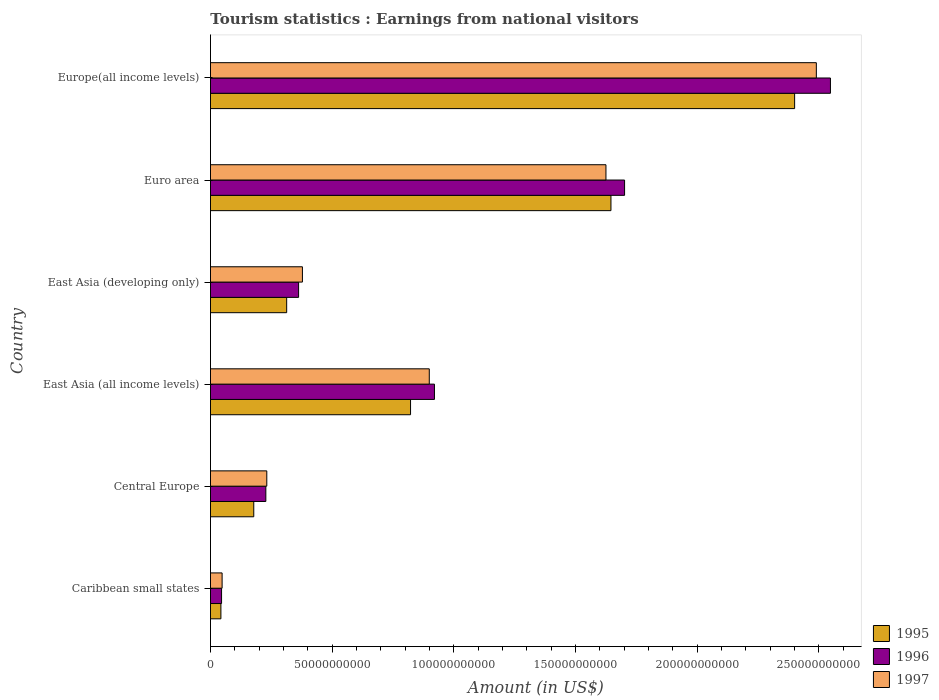How many groups of bars are there?
Make the answer very short. 6. Are the number of bars on each tick of the Y-axis equal?
Provide a short and direct response. Yes. How many bars are there on the 2nd tick from the top?
Provide a short and direct response. 3. How many bars are there on the 3rd tick from the bottom?
Provide a short and direct response. 3. What is the label of the 6th group of bars from the top?
Your answer should be compact. Caribbean small states. In how many cases, is the number of bars for a given country not equal to the number of legend labels?
Your response must be concise. 0. What is the earnings from national visitors in 1997 in Europe(all income levels)?
Your response must be concise. 2.49e+11. Across all countries, what is the maximum earnings from national visitors in 1997?
Give a very brief answer. 2.49e+11. Across all countries, what is the minimum earnings from national visitors in 1996?
Keep it short and to the point. 4.56e+09. In which country was the earnings from national visitors in 1996 maximum?
Provide a short and direct response. Europe(all income levels). In which country was the earnings from national visitors in 1995 minimum?
Provide a short and direct response. Caribbean small states. What is the total earnings from national visitors in 1996 in the graph?
Provide a succinct answer. 5.81e+11. What is the difference between the earnings from national visitors in 1997 in Central Europe and that in East Asia (developing only)?
Keep it short and to the point. -1.46e+1. What is the difference between the earnings from national visitors in 1997 in East Asia (all income levels) and the earnings from national visitors in 1996 in East Asia (developing only)?
Provide a succinct answer. 5.37e+1. What is the average earnings from national visitors in 1996 per country?
Your answer should be very brief. 9.68e+1. What is the difference between the earnings from national visitors in 1997 and earnings from national visitors in 1995 in East Asia (developing only)?
Your response must be concise. 6.47e+09. In how many countries, is the earnings from national visitors in 1997 greater than 90000000000 US$?
Make the answer very short. 2. What is the ratio of the earnings from national visitors in 1995 in East Asia (developing only) to that in Euro area?
Keep it short and to the point. 0.19. Is the earnings from national visitors in 1997 in East Asia (developing only) less than that in Europe(all income levels)?
Provide a succinct answer. Yes. What is the difference between the highest and the second highest earnings from national visitors in 1996?
Make the answer very short. 8.46e+1. What is the difference between the highest and the lowest earnings from national visitors in 1995?
Make the answer very short. 2.36e+11. What does the 3rd bar from the bottom in Caribbean small states represents?
Offer a very short reply. 1997. How many bars are there?
Provide a short and direct response. 18. How many countries are there in the graph?
Ensure brevity in your answer.  6. What is the difference between two consecutive major ticks on the X-axis?
Offer a terse response. 5.00e+1. Are the values on the major ticks of X-axis written in scientific E-notation?
Your response must be concise. No. How many legend labels are there?
Ensure brevity in your answer.  3. What is the title of the graph?
Offer a terse response. Tourism statistics : Earnings from national visitors. What is the label or title of the X-axis?
Give a very brief answer. Amount (in US$). What is the label or title of the Y-axis?
Give a very brief answer. Country. What is the Amount (in US$) in 1995 in Caribbean small states?
Provide a succinct answer. 4.29e+09. What is the Amount (in US$) of 1996 in Caribbean small states?
Provide a succinct answer. 4.56e+09. What is the Amount (in US$) in 1997 in Caribbean small states?
Give a very brief answer. 4.78e+09. What is the Amount (in US$) of 1995 in Central Europe?
Keep it short and to the point. 1.78e+1. What is the Amount (in US$) of 1996 in Central Europe?
Provide a short and direct response. 2.28e+1. What is the Amount (in US$) in 1997 in Central Europe?
Your response must be concise. 2.32e+1. What is the Amount (in US$) in 1995 in East Asia (all income levels)?
Ensure brevity in your answer.  8.22e+1. What is the Amount (in US$) in 1996 in East Asia (all income levels)?
Your response must be concise. 9.21e+1. What is the Amount (in US$) in 1997 in East Asia (all income levels)?
Your answer should be very brief. 8.99e+1. What is the Amount (in US$) of 1995 in East Asia (developing only)?
Your answer should be compact. 3.13e+1. What is the Amount (in US$) in 1996 in East Asia (developing only)?
Your answer should be very brief. 3.62e+1. What is the Amount (in US$) in 1997 in East Asia (developing only)?
Give a very brief answer. 3.78e+1. What is the Amount (in US$) in 1995 in Euro area?
Provide a short and direct response. 1.65e+11. What is the Amount (in US$) in 1996 in Euro area?
Keep it short and to the point. 1.70e+11. What is the Amount (in US$) of 1997 in Euro area?
Your answer should be very brief. 1.63e+11. What is the Amount (in US$) of 1995 in Europe(all income levels)?
Keep it short and to the point. 2.40e+11. What is the Amount (in US$) of 1996 in Europe(all income levels)?
Provide a succinct answer. 2.55e+11. What is the Amount (in US$) of 1997 in Europe(all income levels)?
Provide a succinct answer. 2.49e+11. Across all countries, what is the maximum Amount (in US$) in 1995?
Your response must be concise. 2.40e+11. Across all countries, what is the maximum Amount (in US$) in 1996?
Your response must be concise. 2.55e+11. Across all countries, what is the maximum Amount (in US$) of 1997?
Provide a succinct answer. 2.49e+11. Across all countries, what is the minimum Amount (in US$) in 1995?
Offer a very short reply. 4.29e+09. Across all countries, what is the minimum Amount (in US$) of 1996?
Your response must be concise. 4.56e+09. Across all countries, what is the minimum Amount (in US$) of 1997?
Provide a succinct answer. 4.78e+09. What is the total Amount (in US$) in 1995 in the graph?
Provide a succinct answer. 5.40e+11. What is the total Amount (in US$) in 1996 in the graph?
Ensure brevity in your answer.  5.81e+11. What is the total Amount (in US$) of 1997 in the graph?
Make the answer very short. 5.67e+11. What is the difference between the Amount (in US$) of 1995 in Caribbean small states and that in Central Europe?
Provide a succinct answer. -1.35e+1. What is the difference between the Amount (in US$) of 1996 in Caribbean small states and that in Central Europe?
Your answer should be compact. -1.82e+1. What is the difference between the Amount (in US$) of 1997 in Caribbean small states and that in Central Europe?
Keep it short and to the point. -1.84e+1. What is the difference between the Amount (in US$) of 1995 in Caribbean small states and that in East Asia (all income levels)?
Make the answer very short. -7.79e+1. What is the difference between the Amount (in US$) in 1996 in Caribbean small states and that in East Asia (all income levels)?
Make the answer very short. -8.75e+1. What is the difference between the Amount (in US$) of 1997 in Caribbean small states and that in East Asia (all income levels)?
Keep it short and to the point. -8.52e+1. What is the difference between the Amount (in US$) in 1995 in Caribbean small states and that in East Asia (developing only)?
Your answer should be very brief. -2.70e+1. What is the difference between the Amount (in US$) of 1996 in Caribbean small states and that in East Asia (developing only)?
Provide a short and direct response. -3.17e+1. What is the difference between the Amount (in US$) in 1997 in Caribbean small states and that in East Asia (developing only)?
Offer a terse response. -3.30e+1. What is the difference between the Amount (in US$) of 1995 in Caribbean small states and that in Euro area?
Give a very brief answer. -1.60e+11. What is the difference between the Amount (in US$) of 1996 in Caribbean small states and that in Euro area?
Your response must be concise. -1.66e+11. What is the difference between the Amount (in US$) of 1997 in Caribbean small states and that in Euro area?
Provide a succinct answer. -1.58e+11. What is the difference between the Amount (in US$) in 1995 in Caribbean small states and that in Europe(all income levels)?
Your response must be concise. -2.36e+11. What is the difference between the Amount (in US$) of 1996 in Caribbean small states and that in Europe(all income levels)?
Your response must be concise. -2.50e+11. What is the difference between the Amount (in US$) of 1997 in Caribbean small states and that in Europe(all income levels)?
Make the answer very short. -2.44e+11. What is the difference between the Amount (in US$) of 1995 in Central Europe and that in East Asia (all income levels)?
Offer a terse response. -6.44e+1. What is the difference between the Amount (in US$) in 1996 in Central Europe and that in East Asia (all income levels)?
Make the answer very short. -6.93e+1. What is the difference between the Amount (in US$) of 1997 in Central Europe and that in East Asia (all income levels)?
Ensure brevity in your answer.  -6.68e+1. What is the difference between the Amount (in US$) in 1995 in Central Europe and that in East Asia (developing only)?
Keep it short and to the point. -1.35e+1. What is the difference between the Amount (in US$) in 1996 in Central Europe and that in East Asia (developing only)?
Provide a succinct answer. -1.35e+1. What is the difference between the Amount (in US$) in 1997 in Central Europe and that in East Asia (developing only)?
Provide a succinct answer. -1.46e+1. What is the difference between the Amount (in US$) in 1995 in Central Europe and that in Euro area?
Give a very brief answer. -1.47e+11. What is the difference between the Amount (in US$) of 1996 in Central Europe and that in Euro area?
Your answer should be very brief. -1.47e+11. What is the difference between the Amount (in US$) in 1997 in Central Europe and that in Euro area?
Keep it short and to the point. -1.39e+11. What is the difference between the Amount (in US$) in 1995 in Central Europe and that in Europe(all income levels)?
Give a very brief answer. -2.22e+11. What is the difference between the Amount (in US$) of 1996 in Central Europe and that in Europe(all income levels)?
Make the answer very short. -2.32e+11. What is the difference between the Amount (in US$) of 1997 in Central Europe and that in Europe(all income levels)?
Give a very brief answer. -2.26e+11. What is the difference between the Amount (in US$) of 1995 in East Asia (all income levels) and that in East Asia (developing only)?
Your answer should be compact. 5.09e+1. What is the difference between the Amount (in US$) in 1996 in East Asia (all income levels) and that in East Asia (developing only)?
Keep it short and to the point. 5.58e+1. What is the difference between the Amount (in US$) in 1997 in East Asia (all income levels) and that in East Asia (developing only)?
Ensure brevity in your answer.  5.21e+1. What is the difference between the Amount (in US$) in 1995 in East Asia (all income levels) and that in Euro area?
Provide a succinct answer. -8.24e+1. What is the difference between the Amount (in US$) of 1996 in East Asia (all income levels) and that in Euro area?
Your response must be concise. -7.82e+1. What is the difference between the Amount (in US$) in 1997 in East Asia (all income levels) and that in Euro area?
Your response must be concise. -7.26e+1. What is the difference between the Amount (in US$) in 1995 in East Asia (all income levels) and that in Europe(all income levels)?
Your answer should be very brief. -1.58e+11. What is the difference between the Amount (in US$) in 1996 in East Asia (all income levels) and that in Europe(all income levels)?
Your answer should be compact. -1.63e+11. What is the difference between the Amount (in US$) of 1997 in East Asia (all income levels) and that in Europe(all income levels)?
Your response must be concise. -1.59e+11. What is the difference between the Amount (in US$) in 1995 in East Asia (developing only) and that in Euro area?
Your answer should be compact. -1.33e+11. What is the difference between the Amount (in US$) of 1996 in East Asia (developing only) and that in Euro area?
Your answer should be compact. -1.34e+11. What is the difference between the Amount (in US$) of 1997 in East Asia (developing only) and that in Euro area?
Make the answer very short. -1.25e+11. What is the difference between the Amount (in US$) in 1995 in East Asia (developing only) and that in Europe(all income levels)?
Your answer should be compact. -2.09e+11. What is the difference between the Amount (in US$) of 1996 in East Asia (developing only) and that in Europe(all income levels)?
Offer a terse response. -2.19e+11. What is the difference between the Amount (in US$) in 1997 in East Asia (developing only) and that in Europe(all income levels)?
Keep it short and to the point. -2.11e+11. What is the difference between the Amount (in US$) in 1995 in Euro area and that in Europe(all income levels)?
Offer a very short reply. -7.55e+1. What is the difference between the Amount (in US$) of 1996 in Euro area and that in Europe(all income levels)?
Give a very brief answer. -8.46e+1. What is the difference between the Amount (in US$) of 1997 in Euro area and that in Europe(all income levels)?
Ensure brevity in your answer.  -8.65e+1. What is the difference between the Amount (in US$) of 1995 in Caribbean small states and the Amount (in US$) of 1996 in Central Europe?
Your answer should be compact. -1.85e+1. What is the difference between the Amount (in US$) of 1995 in Caribbean small states and the Amount (in US$) of 1997 in Central Europe?
Give a very brief answer. -1.89e+1. What is the difference between the Amount (in US$) in 1996 in Caribbean small states and the Amount (in US$) in 1997 in Central Europe?
Your answer should be very brief. -1.86e+1. What is the difference between the Amount (in US$) in 1995 in Caribbean small states and the Amount (in US$) in 1996 in East Asia (all income levels)?
Your answer should be very brief. -8.78e+1. What is the difference between the Amount (in US$) of 1995 in Caribbean small states and the Amount (in US$) of 1997 in East Asia (all income levels)?
Provide a short and direct response. -8.56e+1. What is the difference between the Amount (in US$) of 1996 in Caribbean small states and the Amount (in US$) of 1997 in East Asia (all income levels)?
Provide a short and direct response. -8.54e+1. What is the difference between the Amount (in US$) in 1995 in Caribbean small states and the Amount (in US$) in 1996 in East Asia (developing only)?
Ensure brevity in your answer.  -3.19e+1. What is the difference between the Amount (in US$) in 1995 in Caribbean small states and the Amount (in US$) in 1997 in East Asia (developing only)?
Provide a short and direct response. -3.35e+1. What is the difference between the Amount (in US$) of 1996 in Caribbean small states and the Amount (in US$) of 1997 in East Asia (developing only)?
Your answer should be very brief. -3.32e+1. What is the difference between the Amount (in US$) of 1995 in Caribbean small states and the Amount (in US$) of 1996 in Euro area?
Make the answer very short. -1.66e+11. What is the difference between the Amount (in US$) of 1995 in Caribbean small states and the Amount (in US$) of 1997 in Euro area?
Offer a very short reply. -1.58e+11. What is the difference between the Amount (in US$) in 1996 in Caribbean small states and the Amount (in US$) in 1997 in Euro area?
Provide a succinct answer. -1.58e+11. What is the difference between the Amount (in US$) in 1995 in Caribbean small states and the Amount (in US$) in 1996 in Europe(all income levels)?
Make the answer very short. -2.51e+11. What is the difference between the Amount (in US$) in 1995 in Caribbean small states and the Amount (in US$) in 1997 in Europe(all income levels)?
Your answer should be compact. -2.45e+11. What is the difference between the Amount (in US$) of 1996 in Caribbean small states and the Amount (in US$) of 1997 in Europe(all income levels)?
Offer a terse response. -2.44e+11. What is the difference between the Amount (in US$) of 1995 in Central Europe and the Amount (in US$) of 1996 in East Asia (all income levels)?
Keep it short and to the point. -7.43e+1. What is the difference between the Amount (in US$) in 1995 in Central Europe and the Amount (in US$) in 1997 in East Asia (all income levels)?
Make the answer very short. -7.21e+1. What is the difference between the Amount (in US$) of 1996 in Central Europe and the Amount (in US$) of 1997 in East Asia (all income levels)?
Keep it short and to the point. -6.72e+1. What is the difference between the Amount (in US$) in 1995 in Central Europe and the Amount (in US$) in 1996 in East Asia (developing only)?
Make the answer very short. -1.84e+1. What is the difference between the Amount (in US$) of 1995 in Central Europe and the Amount (in US$) of 1997 in East Asia (developing only)?
Offer a terse response. -2.00e+1. What is the difference between the Amount (in US$) of 1996 in Central Europe and the Amount (in US$) of 1997 in East Asia (developing only)?
Your answer should be very brief. -1.50e+1. What is the difference between the Amount (in US$) of 1995 in Central Europe and the Amount (in US$) of 1996 in Euro area?
Your answer should be compact. -1.52e+11. What is the difference between the Amount (in US$) of 1995 in Central Europe and the Amount (in US$) of 1997 in Euro area?
Your response must be concise. -1.45e+11. What is the difference between the Amount (in US$) of 1996 in Central Europe and the Amount (in US$) of 1997 in Euro area?
Your response must be concise. -1.40e+11. What is the difference between the Amount (in US$) of 1995 in Central Europe and the Amount (in US$) of 1996 in Europe(all income levels)?
Provide a short and direct response. -2.37e+11. What is the difference between the Amount (in US$) of 1995 in Central Europe and the Amount (in US$) of 1997 in Europe(all income levels)?
Provide a succinct answer. -2.31e+11. What is the difference between the Amount (in US$) in 1996 in Central Europe and the Amount (in US$) in 1997 in Europe(all income levels)?
Your response must be concise. -2.26e+11. What is the difference between the Amount (in US$) of 1995 in East Asia (all income levels) and the Amount (in US$) of 1996 in East Asia (developing only)?
Ensure brevity in your answer.  4.60e+1. What is the difference between the Amount (in US$) in 1995 in East Asia (all income levels) and the Amount (in US$) in 1997 in East Asia (developing only)?
Offer a terse response. 4.44e+1. What is the difference between the Amount (in US$) of 1996 in East Asia (all income levels) and the Amount (in US$) of 1997 in East Asia (developing only)?
Keep it short and to the point. 5.43e+1. What is the difference between the Amount (in US$) in 1995 in East Asia (all income levels) and the Amount (in US$) in 1996 in Euro area?
Offer a terse response. -8.80e+1. What is the difference between the Amount (in US$) of 1995 in East Asia (all income levels) and the Amount (in US$) of 1997 in Euro area?
Your answer should be very brief. -8.03e+1. What is the difference between the Amount (in US$) in 1996 in East Asia (all income levels) and the Amount (in US$) in 1997 in Euro area?
Offer a very short reply. -7.05e+1. What is the difference between the Amount (in US$) in 1995 in East Asia (all income levels) and the Amount (in US$) in 1996 in Europe(all income levels)?
Offer a very short reply. -1.73e+11. What is the difference between the Amount (in US$) of 1995 in East Asia (all income levels) and the Amount (in US$) of 1997 in Europe(all income levels)?
Provide a succinct answer. -1.67e+11. What is the difference between the Amount (in US$) of 1996 in East Asia (all income levels) and the Amount (in US$) of 1997 in Europe(all income levels)?
Make the answer very short. -1.57e+11. What is the difference between the Amount (in US$) of 1995 in East Asia (developing only) and the Amount (in US$) of 1996 in Euro area?
Ensure brevity in your answer.  -1.39e+11. What is the difference between the Amount (in US$) in 1995 in East Asia (developing only) and the Amount (in US$) in 1997 in Euro area?
Provide a short and direct response. -1.31e+11. What is the difference between the Amount (in US$) of 1996 in East Asia (developing only) and the Amount (in US$) of 1997 in Euro area?
Offer a terse response. -1.26e+11. What is the difference between the Amount (in US$) in 1995 in East Asia (developing only) and the Amount (in US$) in 1996 in Europe(all income levels)?
Provide a succinct answer. -2.24e+11. What is the difference between the Amount (in US$) in 1995 in East Asia (developing only) and the Amount (in US$) in 1997 in Europe(all income levels)?
Your response must be concise. -2.18e+11. What is the difference between the Amount (in US$) in 1996 in East Asia (developing only) and the Amount (in US$) in 1997 in Europe(all income levels)?
Your response must be concise. -2.13e+11. What is the difference between the Amount (in US$) in 1995 in Euro area and the Amount (in US$) in 1996 in Europe(all income levels)?
Offer a terse response. -9.02e+1. What is the difference between the Amount (in US$) in 1995 in Euro area and the Amount (in US$) in 1997 in Europe(all income levels)?
Provide a succinct answer. -8.44e+1. What is the difference between the Amount (in US$) in 1996 in Euro area and the Amount (in US$) in 1997 in Europe(all income levels)?
Your answer should be compact. -7.88e+1. What is the average Amount (in US$) of 1995 per country?
Your response must be concise. 9.01e+1. What is the average Amount (in US$) of 1996 per country?
Offer a very short reply. 9.68e+1. What is the average Amount (in US$) of 1997 per country?
Your answer should be very brief. 9.45e+1. What is the difference between the Amount (in US$) of 1995 and Amount (in US$) of 1996 in Caribbean small states?
Your answer should be compact. -2.66e+08. What is the difference between the Amount (in US$) of 1995 and Amount (in US$) of 1997 in Caribbean small states?
Ensure brevity in your answer.  -4.92e+08. What is the difference between the Amount (in US$) in 1996 and Amount (in US$) in 1997 in Caribbean small states?
Ensure brevity in your answer.  -2.26e+08. What is the difference between the Amount (in US$) in 1995 and Amount (in US$) in 1996 in Central Europe?
Offer a very short reply. -4.96e+09. What is the difference between the Amount (in US$) of 1995 and Amount (in US$) of 1997 in Central Europe?
Your answer should be compact. -5.36e+09. What is the difference between the Amount (in US$) of 1996 and Amount (in US$) of 1997 in Central Europe?
Offer a terse response. -3.92e+08. What is the difference between the Amount (in US$) in 1995 and Amount (in US$) in 1996 in East Asia (all income levels)?
Keep it short and to the point. -9.82e+09. What is the difference between the Amount (in US$) in 1995 and Amount (in US$) in 1997 in East Asia (all income levels)?
Your answer should be very brief. -7.70e+09. What is the difference between the Amount (in US$) of 1996 and Amount (in US$) of 1997 in East Asia (all income levels)?
Make the answer very short. 2.13e+09. What is the difference between the Amount (in US$) of 1995 and Amount (in US$) of 1996 in East Asia (developing only)?
Your answer should be compact. -4.90e+09. What is the difference between the Amount (in US$) in 1995 and Amount (in US$) in 1997 in East Asia (developing only)?
Provide a succinct answer. -6.47e+09. What is the difference between the Amount (in US$) of 1996 and Amount (in US$) of 1997 in East Asia (developing only)?
Provide a short and direct response. -1.57e+09. What is the difference between the Amount (in US$) of 1995 and Amount (in US$) of 1996 in Euro area?
Your response must be concise. -5.60e+09. What is the difference between the Amount (in US$) of 1995 and Amount (in US$) of 1997 in Euro area?
Provide a succinct answer. 2.05e+09. What is the difference between the Amount (in US$) of 1996 and Amount (in US$) of 1997 in Euro area?
Your response must be concise. 7.66e+09. What is the difference between the Amount (in US$) in 1995 and Amount (in US$) in 1996 in Europe(all income levels)?
Your response must be concise. -1.47e+1. What is the difference between the Amount (in US$) in 1995 and Amount (in US$) in 1997 in Europe(all income levels)?
Make the answer very short. -8.92e+09. What is the difference between the Amount (in US$) of 1996 and Amount (in US$) of 1997 in Europe(all income levels)?
Ensure brevity in your answer.  5.79e+09. What is the ratio of the Amount (in US$) in 1995 in Caribbean small states to that in Central Europe?
Provide a succinct answer. 0.24. What is the ratio of the Amount (in US$) in 1996 in Caribbean small states to that in Central Europe?
Keep it short and to the point. 0.2. What is the ratio of the Amount (in US$) in 1997 in Caribbean small states to that in Central Europe?
Your answer should be compact. 0.21. What is the ratio of the Amount (in US$) of 1995 in Caribbean small states to that in East Asia (all income levels)?
Provide a succinct answer. 0.05. What is the ratio of the Amount (in US$) in 1996 in Caribbean small states to that in East Asia (all income levels)?
Your answer should be very brief. 0.05. What is the ratio of the Amount (in US$) in 1997 in Caribbean small states to that in East Asia (all income levels)?
Provide a succinct answer. 0.05. What is the ratio of the Amount (in US$) of 1995 in Caribbean small states to that in East Asia (developing only)?
Provide a succinct answer. 0.14. What is the ratio of the Amount (in US$) of 1996 in Caribbean small states to that in East Asia (developing only)?
Make the answer very short. 0.13. What is the ratio of the Amount (in US$) of 1997 in Caribbean small states to that in East Asia (developing only)?
Provide a succinct answer. 0.13. What is the ratio of the Amount (in US$) in 1995 in Caribbean small states to that in Euro area?
Provide a short and direct response. 0.03. What is the ratio of the Amount (in US$) in 1996 in Caribbean small states to that in Euro area?
Your answer should be compact. 0.03. What is the ratio of the Amount (in US$) in 1997 in Caribbean small states to that in Euro area?
Provide a succinct answer. 0.03. What is the ratio of the Amount (in US$) in 1995 in Caribbean small states to that in Europe(all income levels)?
Your answer should be very brief. 0.02. What is the ratio of the Amount (in US$) in 1996 in Caribbean small states to that in Europe(all income levels)?
Provide a succinct answer. 0.02. What is the ratio of the Amount (in US$) in 1997 in Caribbean small states to that in Europe(all income levels)?
Your response must be concise. 0.02. What is the ratio of the Amount (in US$) in 1995 in Central Europe to that in East Asia (all income levels)?
Provide a short and direct response. 0.22. What is the ratio of the Amount (in US$) in 1996 in Central Europe to that in East Asia (all income levels)?
Ensure brevity in your answer.  0.25. What is the ratio of the Amount (in US$) of 1997 in Central Europe to that in East Asia (all income levels)?
Offer a very short reply. 0.26. What is the ratio of the Amount (in US$) in 1995 in Central Europe to that in East Asia (developing only)?
Give a very brief answer. 0.57. What is the ratio of the Amount (in US$) of 1996 in Central Europe to that in East Asia (developing only)?
Ensure brevity in your answer.  0.63. What is the ratio of the Amount (in US$) in 1997 in Central Europe to that in East Asia (developing only)?
Your response must be concise. 0.61. What is the ratio of the Amount (in US$) of 1995 in Central Europe to that in Euro area?
Provide a short and direct response. 0.11. What is the ratio of the Amount (in US$) of 1996 in Central Europe to that in Euro area?
Offer a terse response. 0.13. What is the ratio of the Amount (in US$) in 1997 in Central Europe to that in Euro area?
Give a very brief answer. 0.14. What is the ratio of the Amount (in US$) in 1995 in Central Europe to that in Europe(all income levels)?
Give a very brief answer. 0.07. What is the ratio of the Amount (in US$) in 1996 in Central Europe to that in Europe(all income levels)?
Keep it short and to the point. 0.09. What is the ratio of the Amount (in US$) in 1997 in Central Europe to that in Europe(all income levels)?
Offer a terse response. 0.09. What is the ratio of the Amount (in US$) of 1995 in East Asia (all income levels) to that in East Asia (developing only)?
Your answer should be compact. 2.63. What is the ratio of the Amount (in US$) in 1996 in East Asia (all income levels) to that in East Asia (developing only)?
Your answer should be compact. 2.54. What is the ratio of the Amount (in US$) of 1997 in East Asia (all income levels) to that in East Asia (developing only)?
Keep it short and to the point. 2.38. What is the ratio of the Amount (in US$) of 1995 in East Asia (all income levels) to that in Euro area?
Your response must be concise. 0.5. What is the ratio of the Amount (in US$) of 1996 in East Asia (all income levels) to that in Euro area?
Your answer should be compact. 0.54. What is the ratio of the Amount (in US$) of 1997 in East Asia (all income levels) to that in Euro area?
Offer a terse response. 0.55. What is the ratio of the Amount (in US$) in 1995 in East Asia (all income levels) to that in Europe(all income levels)?
Provide a short and direct response. 0.34. What is the ratio of the Amount (in US$) of 1996 in East Asia (all income levels) to that in Europe(all income levels)?
Your response must be concise. 0.36. What is the ratio of the Amount (in US$) of 1997 in East Asia (all income levels) to that in Europe(all income levels)?
Make the answer very short. 0.36. What is the ratio of the Amount (in US$) in 1995 in East Asia (developing only) to that in Euro area?
Your answer should be compact. 0.19. What is the ratio of the Amount (in US$) in 1996 in East Asia (developing only) to that in Euro area?
Provide a short and direct response. 0.21. What is the ratio of the Amount (in US$) in 1997 in East Asia (developing only) to that in Euro area?
Offer a terse response. 0.23. What is the ratio of the Amount (in US$) in 1995 in East Asia (developing only) to that in Europe(all income levels)?
Your response must be concise. 0.13. What is the ratio of the Amount (in US$) in 1996 in East Asia (developing only) to that in Europe(all income levels)?
Provide a succinct answer. 0.14. What is the ratio of the Amount (in US$) of 1997 in East Asia (developing only) to that in Europe(all income levels)?
Give a very brief answer. 0.15. What is the ratio of the Amount (in US$) of 1995 in Euro area to that in Europe(all income levels)?
Offer a terse response. 0.69. What is the ratio of the Amount (in US$) in 1996 in Euro area to that in Europe(all income levels)?
Your answer should be compact. 0.67. What is the ratio of the Amount (in US$) of 1997 in Euro area to that in Europe(all income levels)?
Your response must be concise. 0.65. What is the difference between the highest and the second highest Amount (in US$) in 1995?
Provide a short and direct response. 7.55e+1. What is the difference between the highest and the second highest Amount (in US$) of 1996?
Provide a succinct answer. 8.46e+1. What is the difference between the highest and the second highest Amount (in US$) in 1997?
Offer a terse response. 8.65e+1. What is the difference between the highest and the lowest Amount (in US$) in 1995?
Give a very brief answer. 2.36e+11. What is the difference between the highest and the lowest Amount (in US$) in 1996?
Provide a short and direct response. 2.50e+11. What is the difference between the highest and the lowest Amount (in US$) of 1997?
Give a very brief answer. 2.44e+11. 